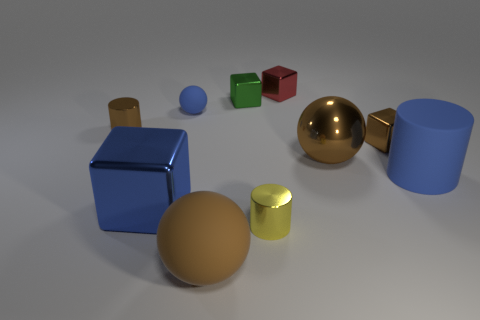What size is the shiny cube that is behind the tiny green thing to the left of the blue rubber thing that is in front of the brown metallic ball?
Your response must be concise. Small. What is the size of the shiny block that is the same color as the large metallic sphere?
Make the answer very short. Small. Is the red metal object the same size as the blue metallic object?
Make the answer very short. No. What is the color of the ball that is the same size as the brown metal cube?
Your answer should be very brief. Blue. Is the green metallic object the same shape as the red thing?
Provide a short and direct response. Yes. There is a brown thing in front of the big blue matte thing; what is it made of?
Offer a very short reply. Rubber. The large cube has what color?
Provide a succinct answer. Blue. Does the rubber sphere behind the yellow thing have the same size as the ball in front of the blue metal block?
Provide a succinct answer. No. How big is the matte thing that is behind the big rubber sphere and on the left side of the tiny brown metal cube?
Your response must be concise. Small. There is a big thing that is the same shape as the small yellow object; what color is it?
Keep it short and to the point. Blue. 